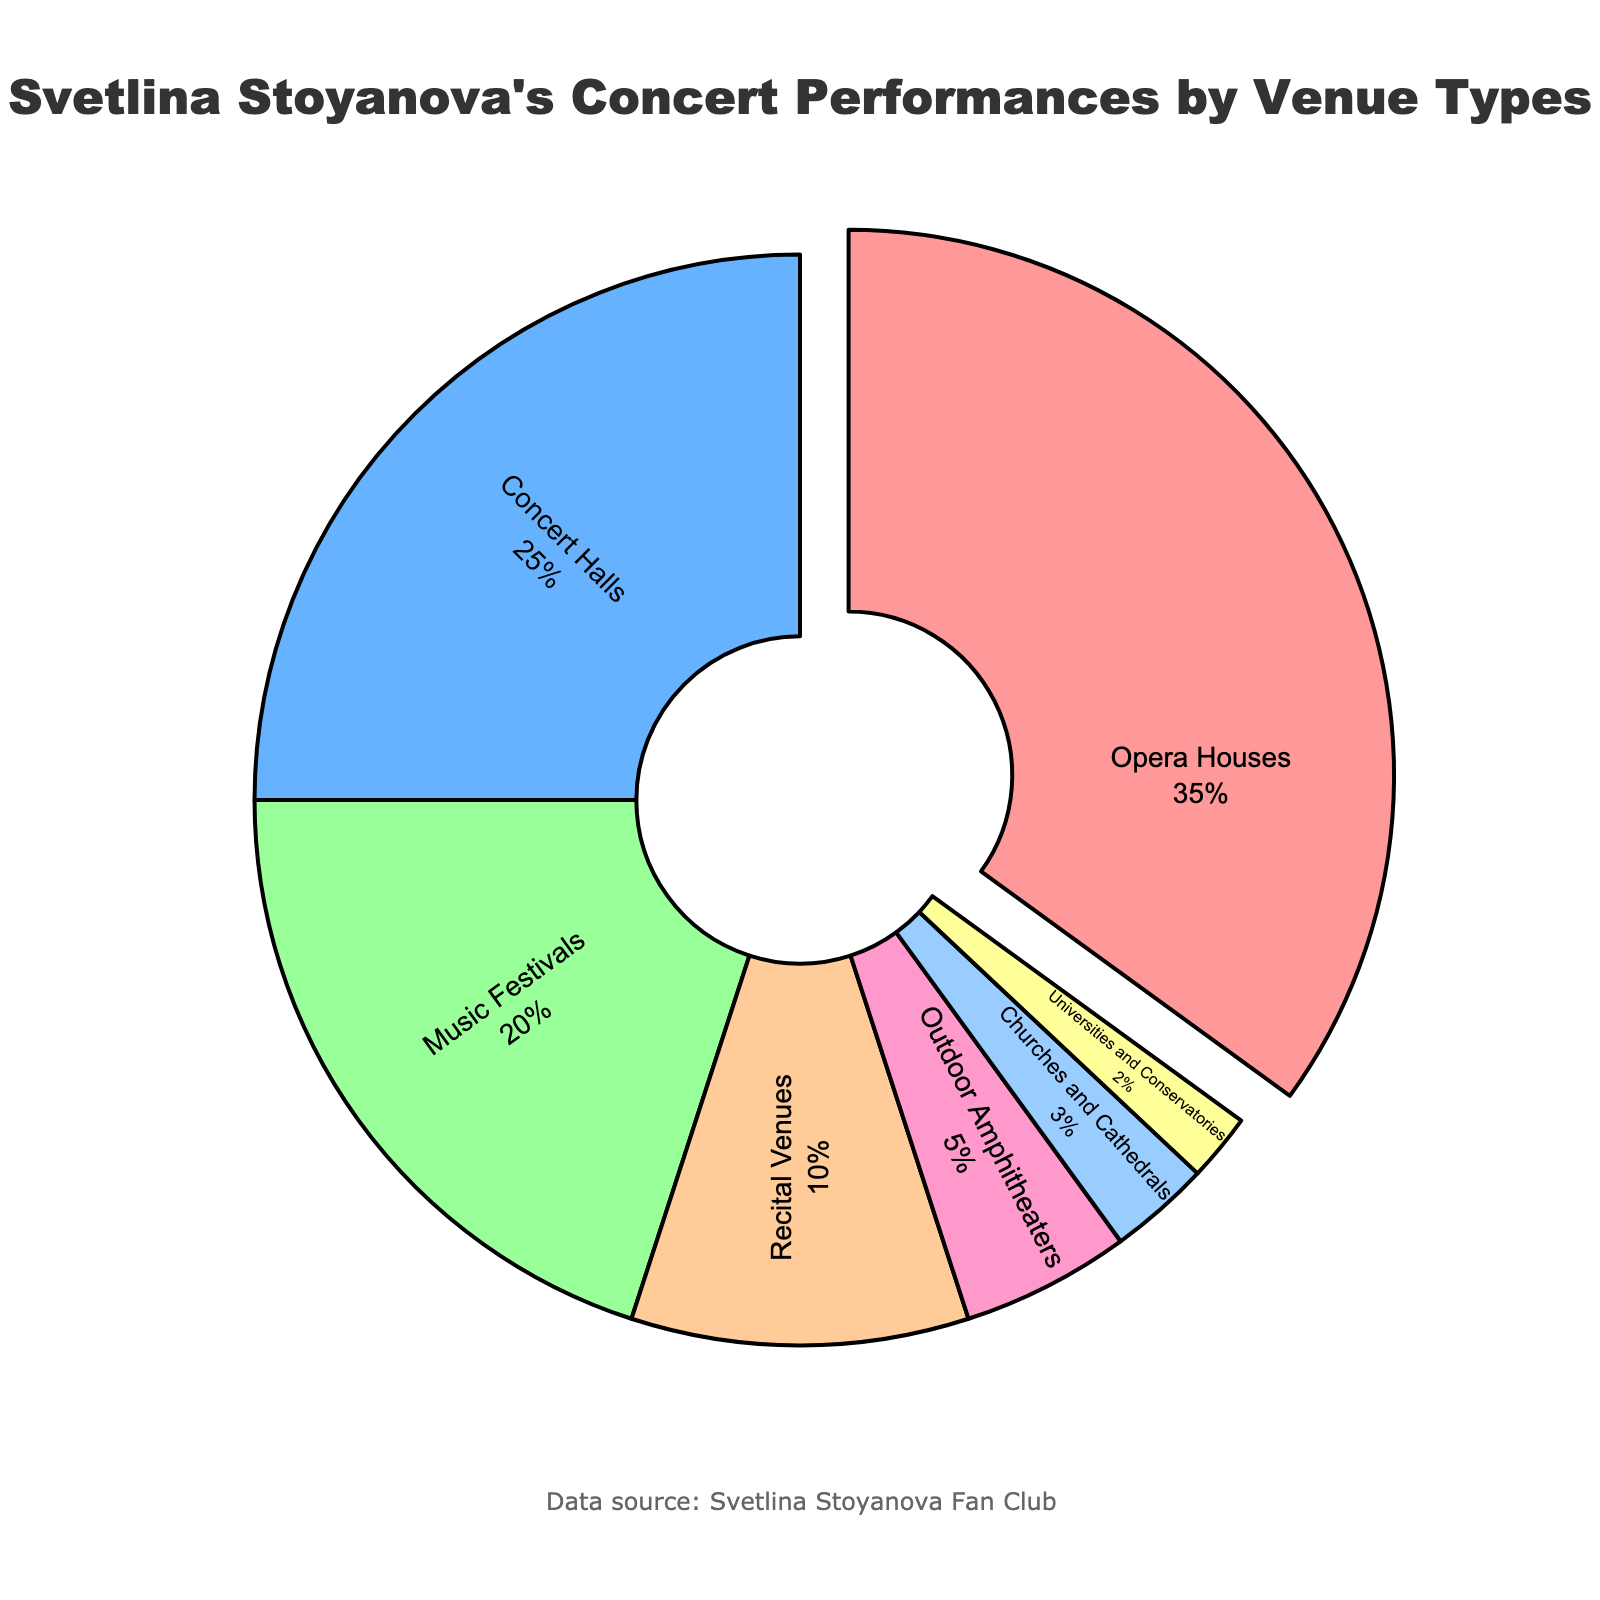Which venue type has the highest percentage in Svetlina Stoyanova's concert performances? The slice representing Opera Houses is the largest in the chart and was also pulled out from the chart, indicating it has the highest percentage.
Answer: Opera Houses How many venue types account for more than half of her performances combined? Summing up the percentages of Opera Houses and Concert Halls, which are the two largest slices: 35% + 25% = 60%, which is more than half of her performances.
Answer: 2 Which venue types contribute to less than 10% of Svetlina Stoyanova's concert performances each? Identifying slices with less than 10%: Recital Venues (10%), Outdoor Amphitheaters (5%), Churches and Cathedrals (3%), and Universities and Conservatories (2%). The sum of these is under 10%.
Answer: Outdoor Amphitheaters, Churches and Cathedrals, and Universities and Conservatories What is the total percentage of performances at Opera Houses, Concert Halls, and Music Festivals? Adding the percentages of Opera Houses, Concert Halls, and Music Festivals: 35% + 25% + 20% = 80%.
Answer: 80% Which venues' performance percentages are equal to those whose combined total is approximately half of the Concert Halls' percentage? Recital Venues (10%) and Outdoor Amphitheaters (5%) together sum up to 15%, which is approximately half of Concert Halls' 25%.
Answer: Recital Venues and Outdoor Amphitheaters What percentage difference exists between performances at Music Festivals and Recital Venues? The percentage for Music Festivals is 20% and for Recital Venues is 10%. The difference is 20% - 10% = 10%.
Answer: 10% What color represents the smallest percentage of venue type in the pie chart? Universities and Conservatories, representing 2%, are displayed in the yellow color as the colors follow the order provided. By observing the chart, the smallest slice is yellow.
Answer: Yellow How does the percentage of performances at Churches and Cathedrals compare to that of Recital Venues? Churches and Cathedrals have 3%, whereas Recital Venues have 10%. 3% is less than 10%.
Answer: Less than If Svetlina Stoyanova had an equal number of performances at each venue type, what would be the new expected percentage for each? With 7 venue types and an equal distribution, the percentage for each would be 100% divided by 7, which equals approximately 14.3%.
Answer: Approximately 14.3% What is the combined percentage of performances at venues that are neither Concert Halls nor Recital Venues? Adding the percentages of Opera Houses (35%), Music Festivals (20%), Outdoor Amphitheaters (5%), Churches and Cathedrals (3%), and Universities and Conservatories (2%): 35% + 20% + 5% + 3% + 2% = 65%.
Answer: 65% 